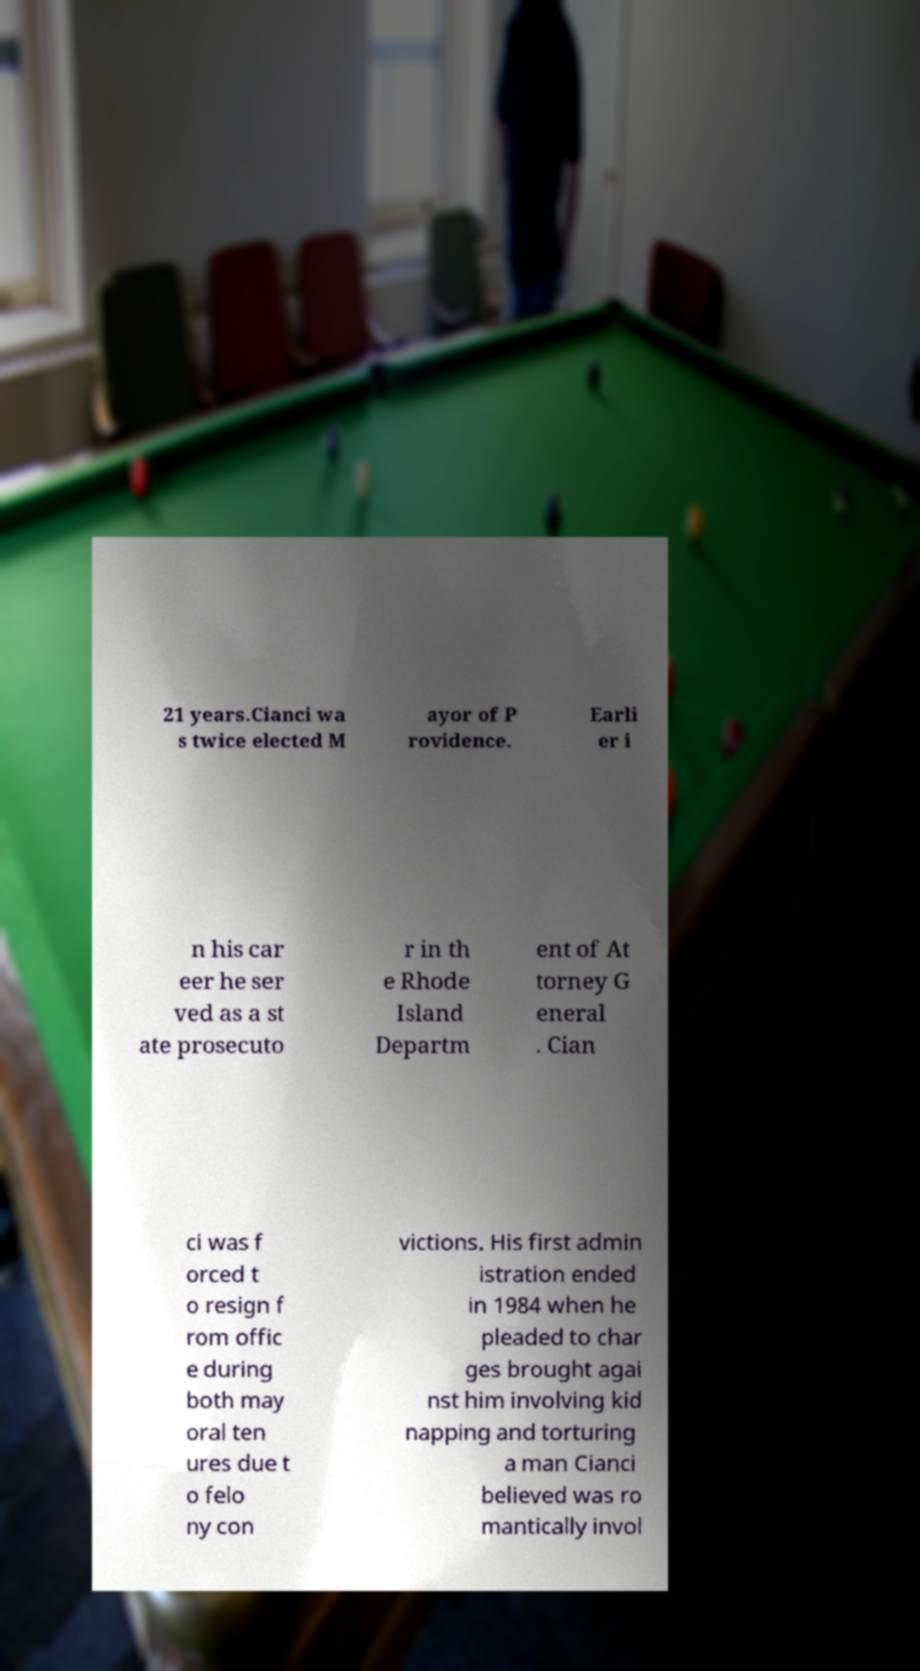I need the written content from this picture converted into text. Can you do that? 21 years.Cianci wa s twice elected M ayor of P rovidence. Earli er i n his car eer he ser ved as a st ate prosecuto r in th e Rhode Island Departm ent of At torney G eneral . Cian ci was f orced t o resign f rom offic e during both may oral ten ures due t o felo ny con victions. His first admin istration ended in 1984 when he pleaded to char ges brought agai nst him involving kid napping and torturing a man Cianci believed was ro mantically invol 